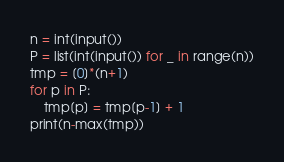Convert code to text. <code><loc_0><loc_0><loc_500><loc_500><_Python_>n = int(input())
P = list(int(input()) for _ in range(n))
tmp = [0]*(n+1)
for p in P:
    tmp[p] = tmp[p-1] + 1
print(n-max(tmp))</code> 